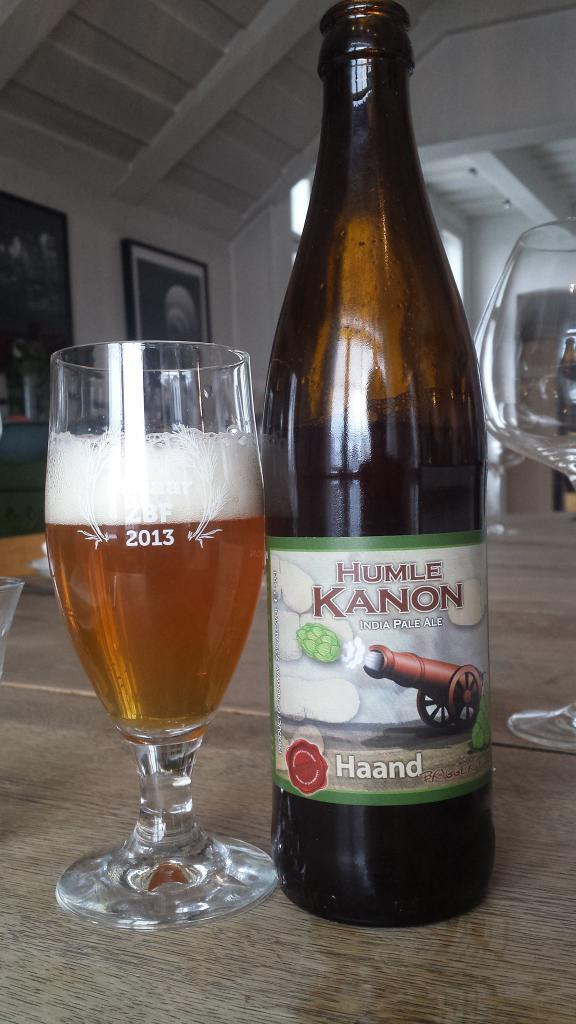What is present in the image that can hold liquid? There is a bottle and glasses in the image that can hold liquid. What is on the bottle in the image? The bottle has a sticker on it. What is the state of one of the glasses in the image? One glass is filled with liquid and foam. What can be seen on the wall in the image? There are pictures on the wall in the image. What day of the week is indicated on the calendar in the image? There is no calendar present in the image. What time is shown on the clock in the image? There is no clock present in the image. 